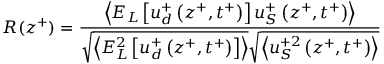Convert formula to latex. <formula><loc_0><loc_0><loc_500><loc_500>R ( z ^ { + } ) = \frac { \left < E _ { L } \left [ u _ { d } ^ { + } \left ( z ^ { + } , t ^ { + } \right ) \right ] u _ { S } ^ { + } \left ( z ^ { + } , t ^ { + } \right ) \right > } { \sqrt { \left < E _ { L } ^ { 2 } \left [ u _ { d } ^ { + } \left ( z ^ { + } , t ^ { + } \right ) \right ] \right > } \sqrt { \left < u _ { S } ^ { + 2 } \left ( z ^ { + } , t ^ { + } \right ) \right > } }</formula> 